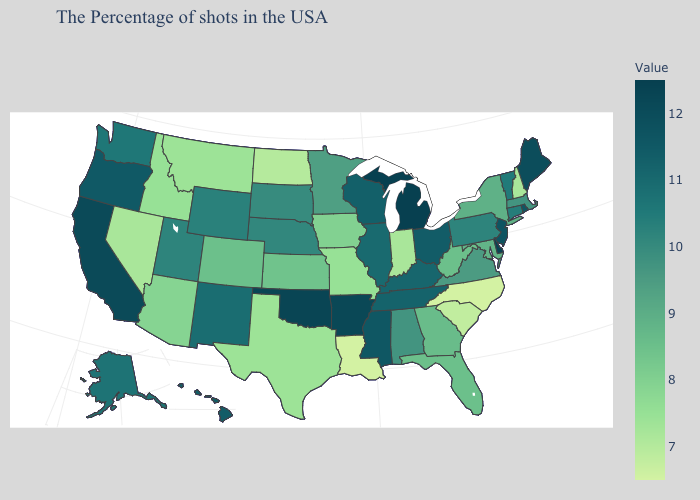Does Michigan have the highest value in the MidWest?
Write a very short answer. Yes. Does the map have missing data?
Write a very short answer. No. Is the legend a continuous bar?
Write a very short answer. Yes. Which states have the lowest value in the South?
Short answer required. North Carolina, Louisiana. Does North Dakota have the lowest value in the MidWest?
Be succinct. Yes. Does North Carolina have the lowest value in the USA?
Keep it brief. Yes. 